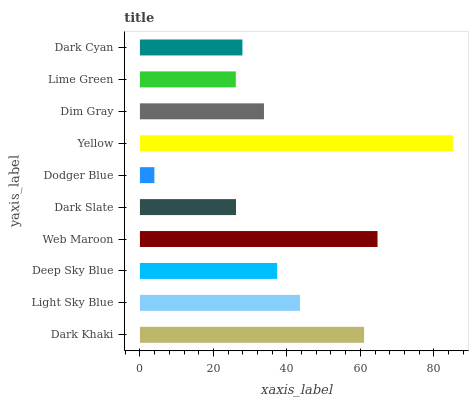Is Dodger Blue the minimum?
Answer yes or no. Yes. Is Yellow the maximum?
Answer yes or no. Yes. Is Light Sky Blue the minimum?
Answer yes or no. No. Is Light Sky Blue the maximum?
Answer yes or no. No. Is Dark Khaki greater than Light Sky Blue?
Answer yes or no. Yes. Is Light Sky Blue less than Dark Khaki?
Answer yes or no. Yes. Is Light Sky Blue greater than Dark Khaki?
Answer yes or no. No. Is Dark Khaki less than Light Sky Blue?
Answer yes or no. No. Is Deep Sky Blue the high median?
Answer yes or no. Yes. Is Dim Gray the low median?
Answer yes or no. Yes. Is Dodger Blue the high median?
Answer yes or no. No. Is Deep Sky Blue the low median?
Answer yes or no. No. 